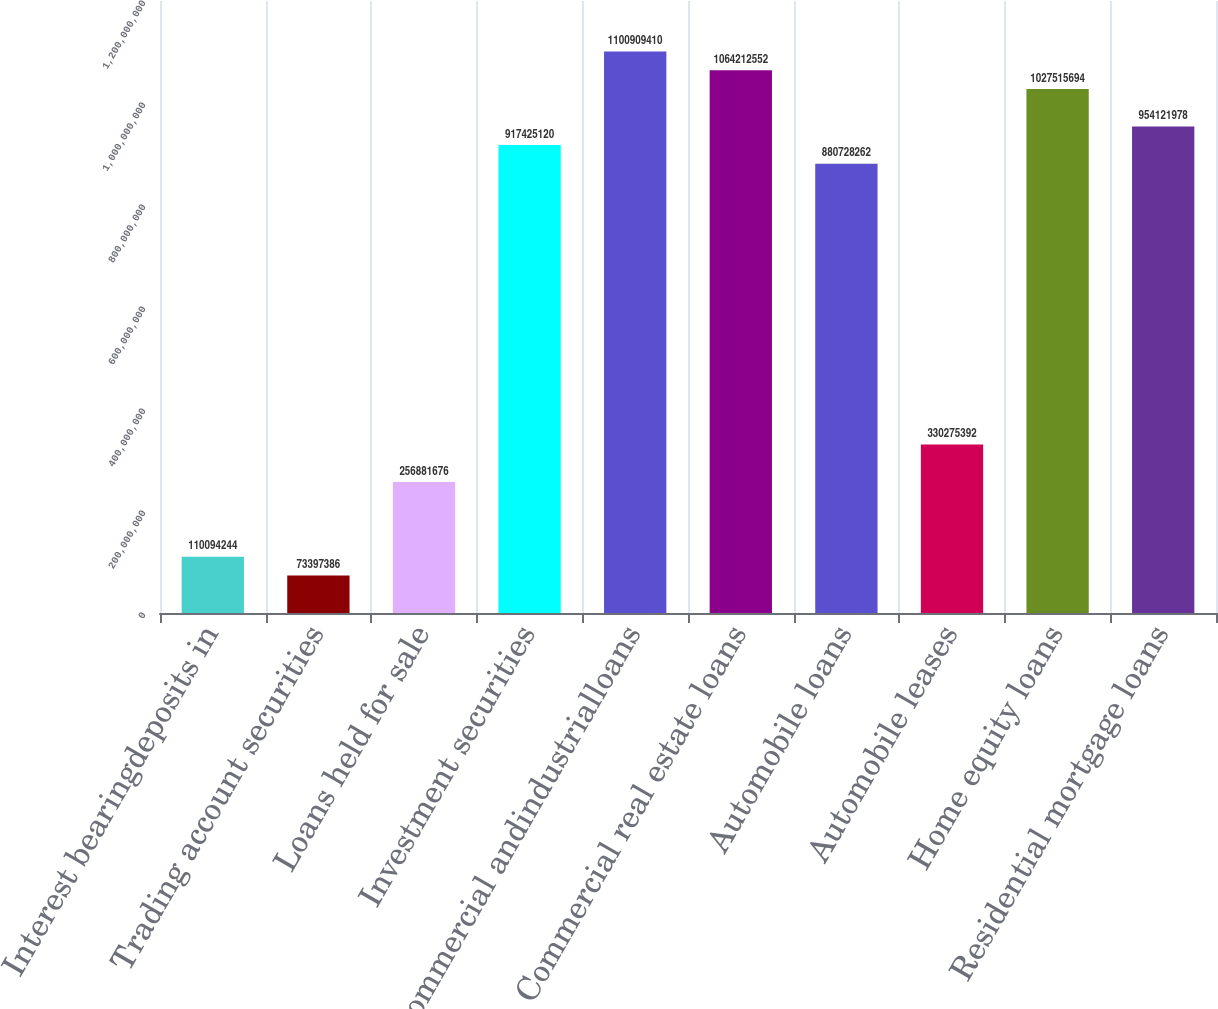<chart> <loc_0><loc_0><loc_500><loc_500><bar_chart><fcel>Interest bearingdeposits in<fcel>Trading account securities<fcel>Loans held for sale<fcel>Investment securities<fcel>Commercial andindustrialloans<fcel>Commercial real estate loans<fcel>Automobile loans<fcel>Automobile leases<fcel>Home equity loans<fcel>Residential mortgage loans<nl><fcel>1.10094e+08<fcel>7.33974e+07<fcel>2.56882e+08<fcel>9.17425e+08<fcel>1.10091e+09<fcel>1.06421e+09<fcel>8.80728e+08<fcel>3.30275e+08<fcel>1.02752e+09<fcel>9.54122e+08<nl></chart> 